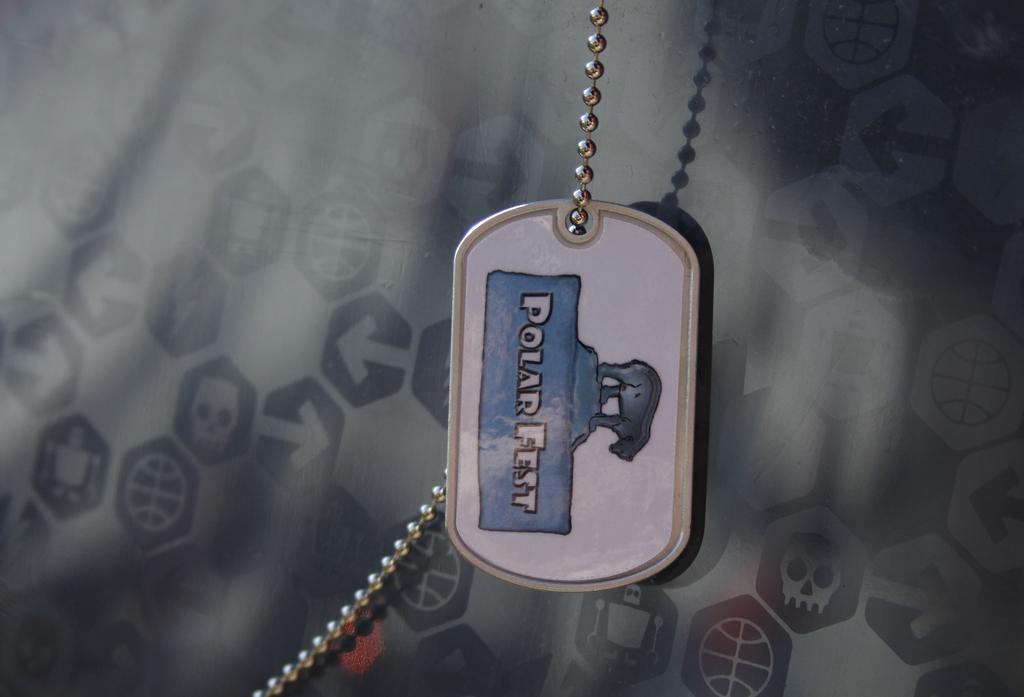Can you describe this image briefly? In this image there is a locket of a polar bear to a chain, and in the background there are symbols of skulls, robots , arrows, balls. 